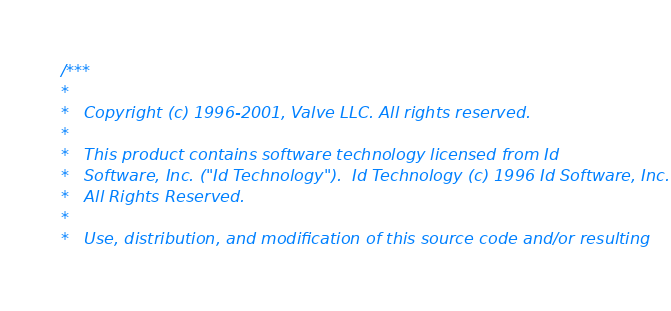<code> <loc_0><loc_0><loc_500><loc_500><_C_>/***
*
*	Copyright (c) 1996-2001, Valve LLC. All rights reserved.
*	
*	This product contains software technology licensed from Id 
*	Software, Inc. ("Id Technology").  Id Technology (c) 1996 Id Software, Inc. 
*	All Rights Reserved.
*
*   Use, distribution, and modification of this source code and/or resulting</code> 